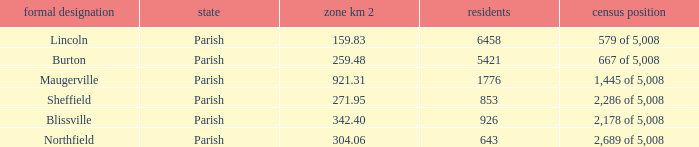What are the census ranking(s) of maugerville? 1,445 of 5,008. 